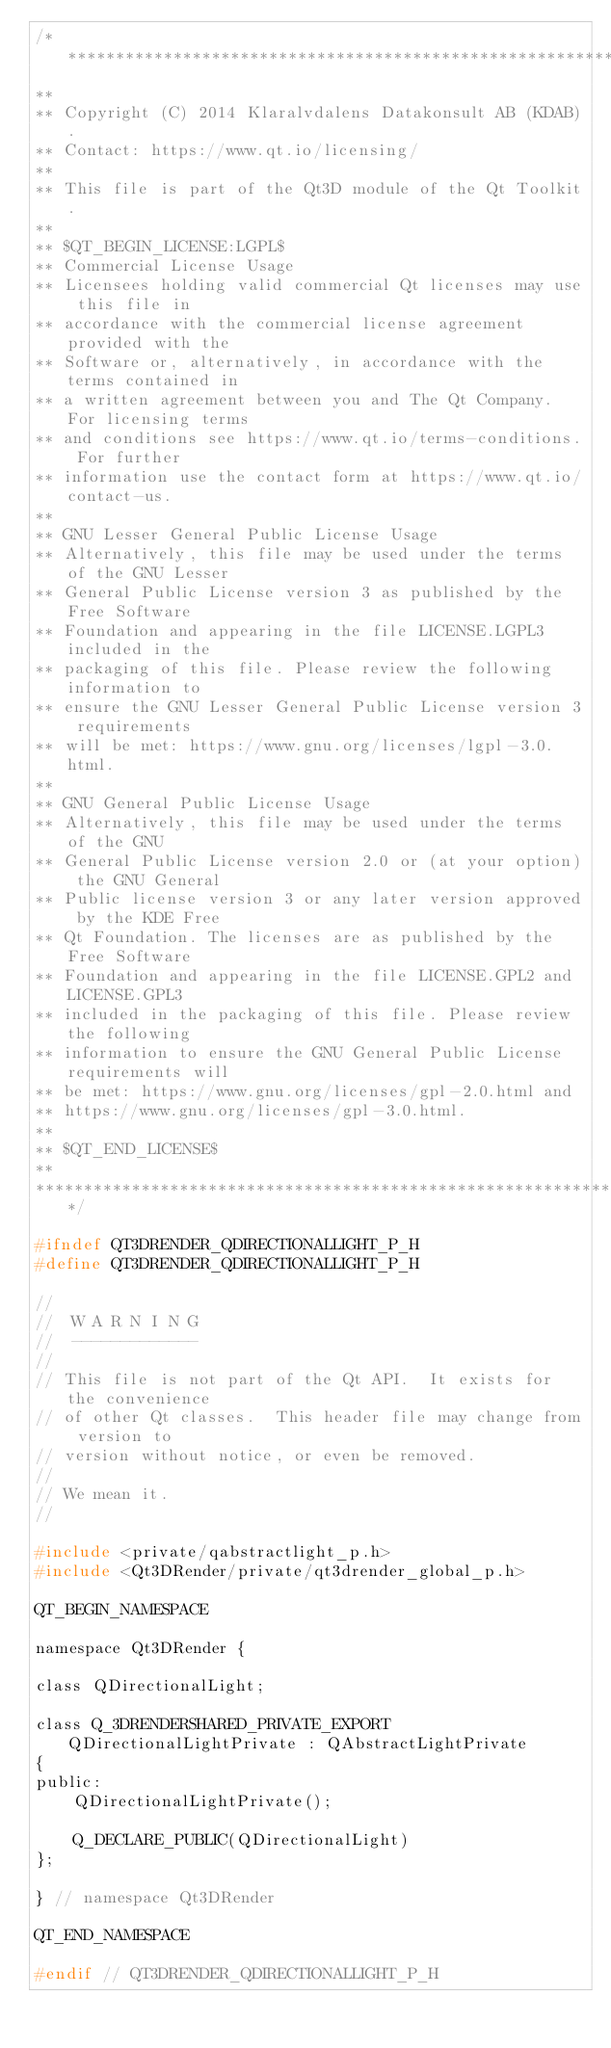<code> <loc_0><loc_0><loc_500><loc_500><_C_>/****************************************************************************
**
** Copyright (C) 2014 Klaralvdalens Datakonsult AB (KDAB).
** Contact: https://www.qt.io/licensing/
**
** This file is part of the Qt3D module of the Qt Toolkit.
**
** $QT_BEGIN_LICENSE:LGPL$
** Commercial License Usage
** Licensees holding valid commercial Qt licenses may use this file in
** accordance with the commercial license agreement provided with the
** Software or, alternatively, in accordance with the terms contained in
** a written agreement between you and The Qt Company. For licensing terms
** and conditions see https://www.qt.io/terms-conditions. For further
** information use the contact form at https://www.qt.io/contact-us.
**
** GNU Lesser General Public License Usage
** Alternatively, this file may be used under the terms of the GNU Lesser
** General Public License version 3 as published by the Free Software
** Foundation and appearing in the file LICENSE.LGPL3 included in the
** packaging of this file. Please review the following information to
** ensure the GNU Lesser General Public License version 3 requirements
** will be met: https://www.gnu.org/licenses/lgpl-3.0.html.
**
** GNU General Public License Usage
** Alternatively, this file may be used under the terms of the GNU
** General Public License version 2.0 or (at your option) the GNU General
** Public license version 3 or any later version approved by the KDE Free
** Qt Foundation. The licenses are as published by the Free Software
** Foundation and appearing in the file LICENSE.GPL2 and LICENSE.GPL3
** included in the packaging of this file. Please review the following
** information to ensure the GNU General Public License requirements will
** be met: https://www.gnu.org/licenses/gpl-2.0.html and
** https://www.gnu.org/licenses/gpl-3.0.html.
**
** $QT_END_LICENSE$
**
****************************************************************************/

#ifndef QT3DRENDER_QDIRECTIONALLIGHT_P_H
#define QT3DRENDER_QDIRECTIONALLIGHT_P_H

//
//  W A R N I N G
//  -------------
//
// This file is not part of the Qt API.  It exists for the convenience
// of other Qt classes.  This header file may change from version to
// version without notice, or even be removed.
//
// We mean it.
//

#include <private/qabstractlight_p.h>
#include <Qt3DRender/private/qt3drender_global_p.h>

QT_BEGIN_NAMESPACE

namespace Qt3DRender {

class QDirectionalLight;

class Q_3DRENDERSHARED_PRIVATE_EXPORT QDirectionalLightPrivate : QAbstractLightPrivate
{
public:
    QDirectionalLightPrivate();

    Q_DECLARE_PUBLIC(QDirectionalLight)
};

} // namespace Qt3DRender

QT_END_NAMESPACE

#endif // QT3DRENDER_QDIRECTIONALLIGHT_P_H
</code> 